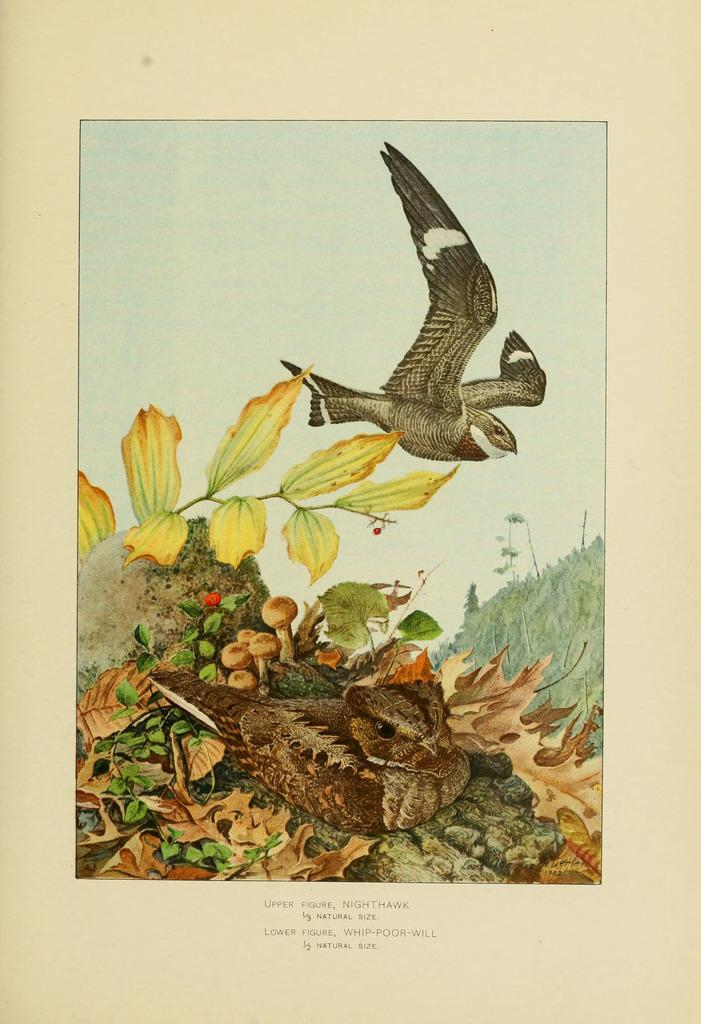What type of visual content is the image? The image is a poster. What is happening in the sky on the poster? There is a bird flying in the air on the poster. What type of vegetation is depicted on the poster? There are leaves depicted on the poster. What type of fungus is depicted on the poster? There is a mushroom depicted on the poster. Are there any other animals depicted on the poster besides the flying bird? Yes, there is another bird depicted on the poster. What type of current is flowing through the mushroom in the image? There is no current depicted in the image, as it features a poster with a bird, leaves, and a mushroom. 